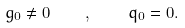Convert formula to latex. <formula><loc_0><loc_0><loc_500><loc_500>g _ { 0 } \neq 0 \quad , \quad q _ { 0 } = 0 .</formula> 